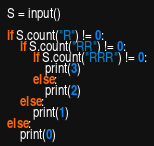Convert code to text. <code><loc_0><loc_0><loc_500><loc_500><_Python_>S = input()

if S.count("R") != 0: 
    if S.count("RR") != 0:
        if S.count("RRR") != 0:
            print(3)
        else:
            print(2)
    else:
        print(1)
else:
    print(0)</code> 